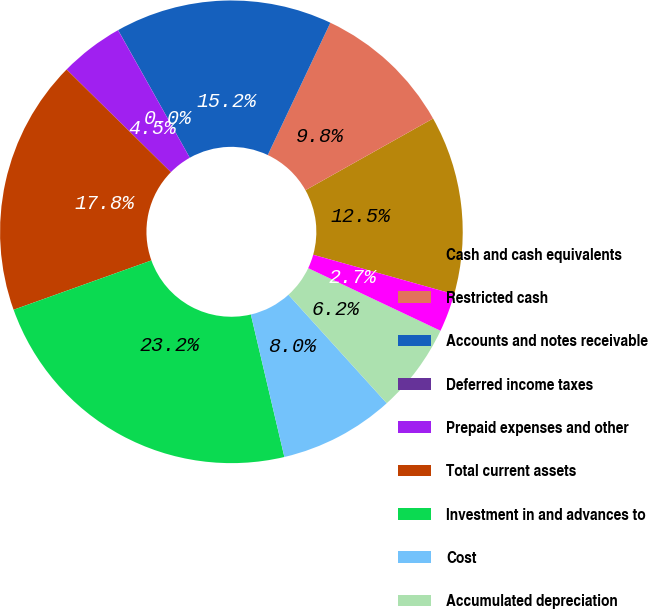Convert chart. <chart><loc_0><loc_0><loc_500><loc_500><pie_chart><fcel>Cash and cash equivalents<fcel>Restricted cash<fcel>Accounts and notes receivable<fcel>Deferred income taxes<fcel>Prepaid expenses and other<fcel>Total current assets<fcel>Investment in and advances to<fcel>Cost<fcel>Accumulated depreciation<fcel>Office equipment net<nl><fcel>12.5%<fcel>9.82%<fcel>15.18%<fcel>0.01%<fcel>4.47%<fcel>17.85%<fcel>23.21%<fcel>8.04%<fcel>6.25%<fcel>2.68%<nl></chart> 